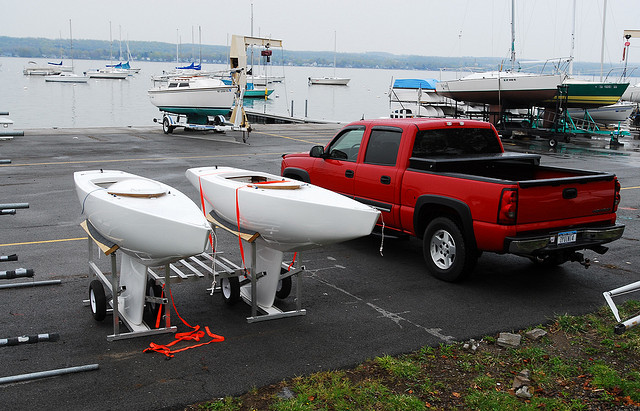<image>What kind of event is this? The event is ambiguous. It could be a regatta, boating event or a boat show. What kind of event is this? I am not sure what kind of event this is. It can be either a regatta or a boating event. 